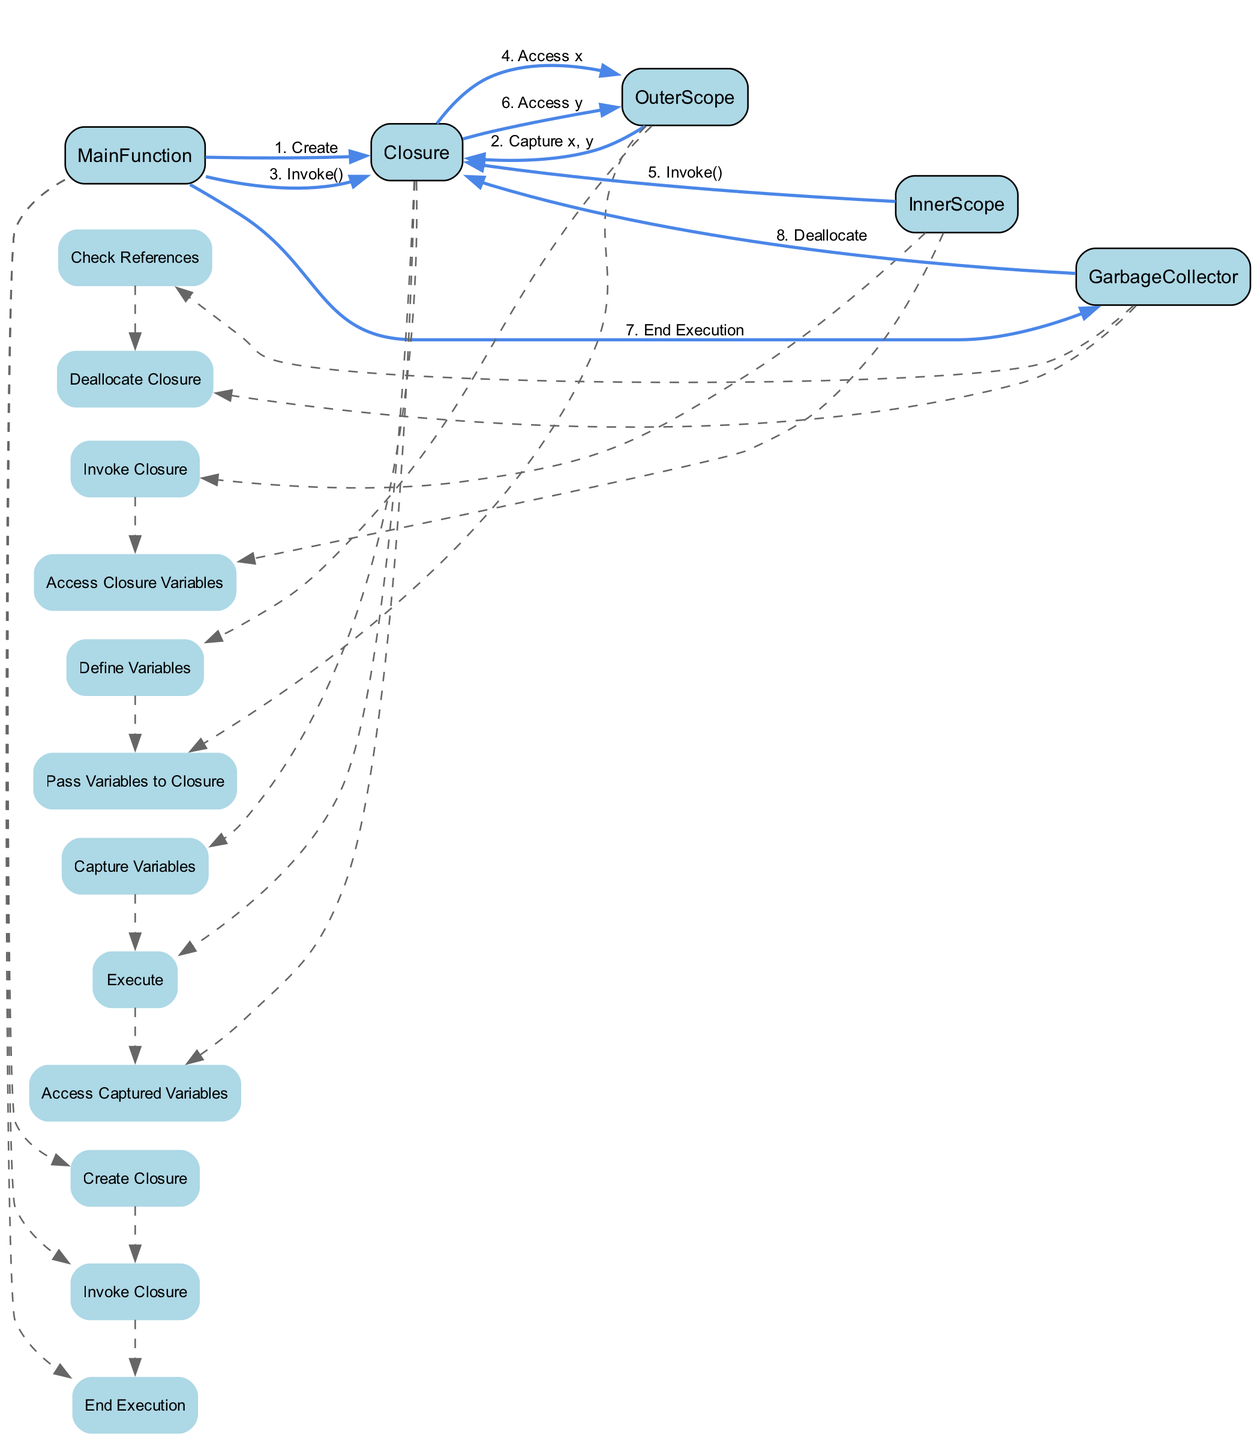What is the first event in the MainFunction? In the lifelines of the diagram, the events for MainFunction are listed, and the first event mentioned is "Create Closure".
Answer: Create Closure How many variables does the Closure capture? The message from OuterScope to Closure states, "Capture x, y", indicating that there are two variables captured by the Closure.
Answer: Two Which scope invokes the Closure twice? The events show that both the MainFunction and the InnerScope invoke the Closure. Since we are looking for the one that invokes it twice, the InnerScope is the correct answer, as it specifically invokes the Closure after-accessing operations.
Answer: InnerScope What does the GarbageCollector do after "End Execution"? The GarbageCollector checks references as per its sequence of events and subsequently deallocates the Closure, making this the operation done after the end of execution.
Answer: Deallocate What messages are sent from Closure to OuterScope? There are two distinct events where Closure accesses the captured variables x and y, emitting messages in this sequence: "Access x" and "Access y".
Answer: Access x, Access y How many lifelines are represented in the diagram? The diagram lists five participants: MainFunction, Closure, OuterScope, InnerScope, and GarbageCollector, which correspond to the lifelines represented. Therefore, the count of lifelines presented is five.
Answer: Five Which participant defines variables in this diagram? The sequence indicates that the OuterScope defines variables before passing them to the Closure, establishing it as the relevant participant for variable definition.
Answer: OuterScope What is the last event for Closure before garbage collection? The final action indicated for Closure is to "Access y", which precedes garbage collection related activities, marking it as the last operational event.
Answer: Access y 